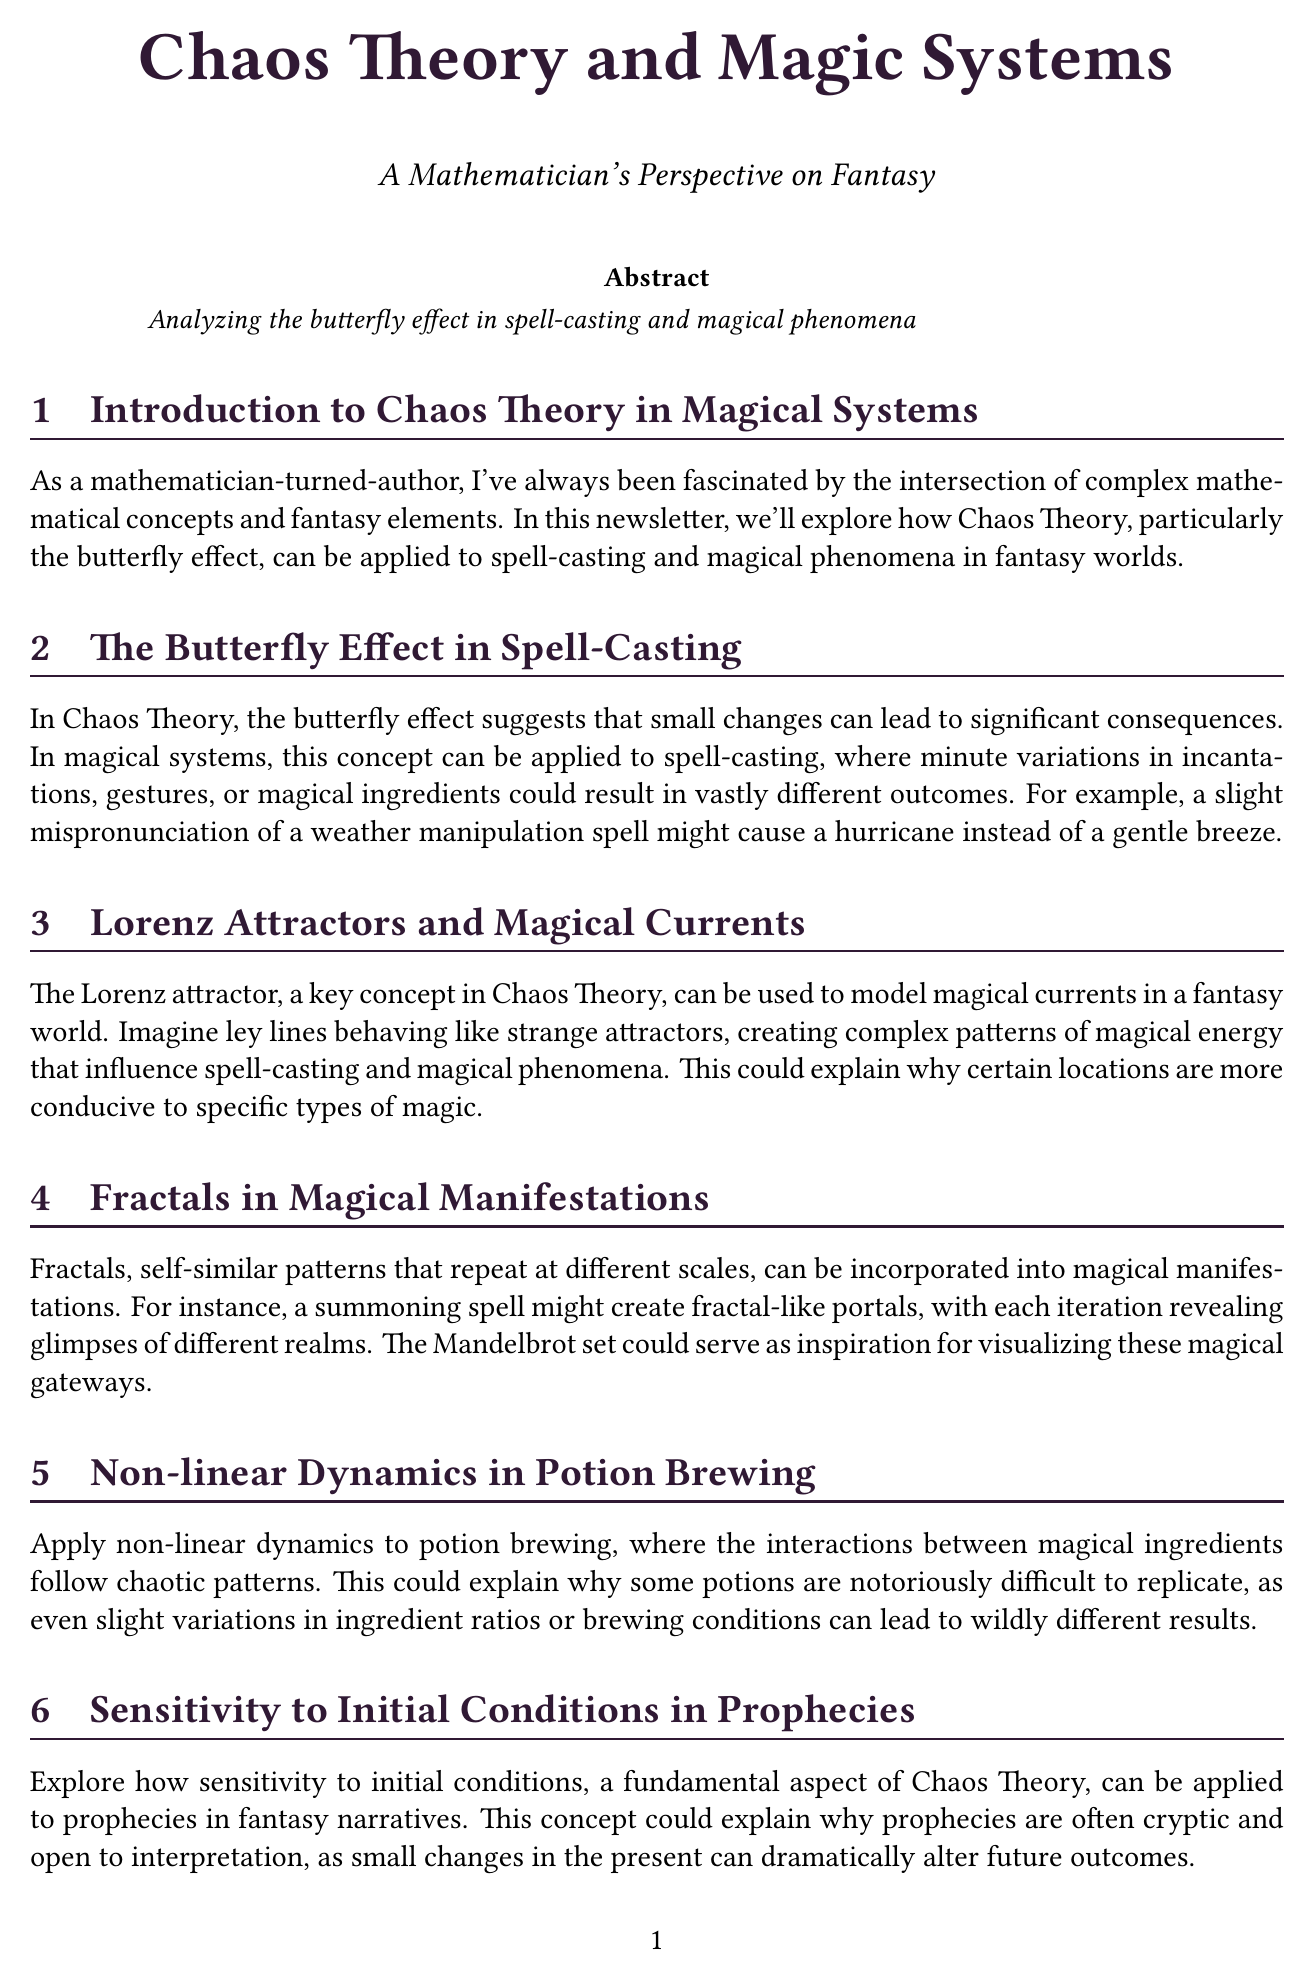What is the title of the newsletter? The title is found at the beginning of the document and summarizes the theme of the newsletter.
Answer: Chaos Theory and Magic Systems Who is the author of the newsletter? The author is mentioned in the title section of the document.
Answer: A Mathematician's Perspective on Fantasy What is the book recommended in the newsletter? The recommended book is specified in the book recommendation section of the document.
Answer: Chaos: Making a New Science What concept does the butterfly effect illustrate in spell-casting? The butterfly effect description is presented in the section focused on spell-casting.
Answer: Significant consequences What mathematical concept is used to explain magical currents? The document mentions a mathematical concept in relation to magical currents.
Answer: Lorenz attractors What patterns are used in magical manifestations? The section on magical manifestations discusses specific patterns.
Answer: Fractals What does sensitivity to initial conditions explain in prophecies? The document discusses how a specific aspect of chaos theory can be applied to prophecies.
Answer: Cryptic and open to interpretation What is the suggested writing exercise about? The writing exercise section details what the readers should do related to Chaos Theory.
Answer: Create a spell or magical phenomenon 